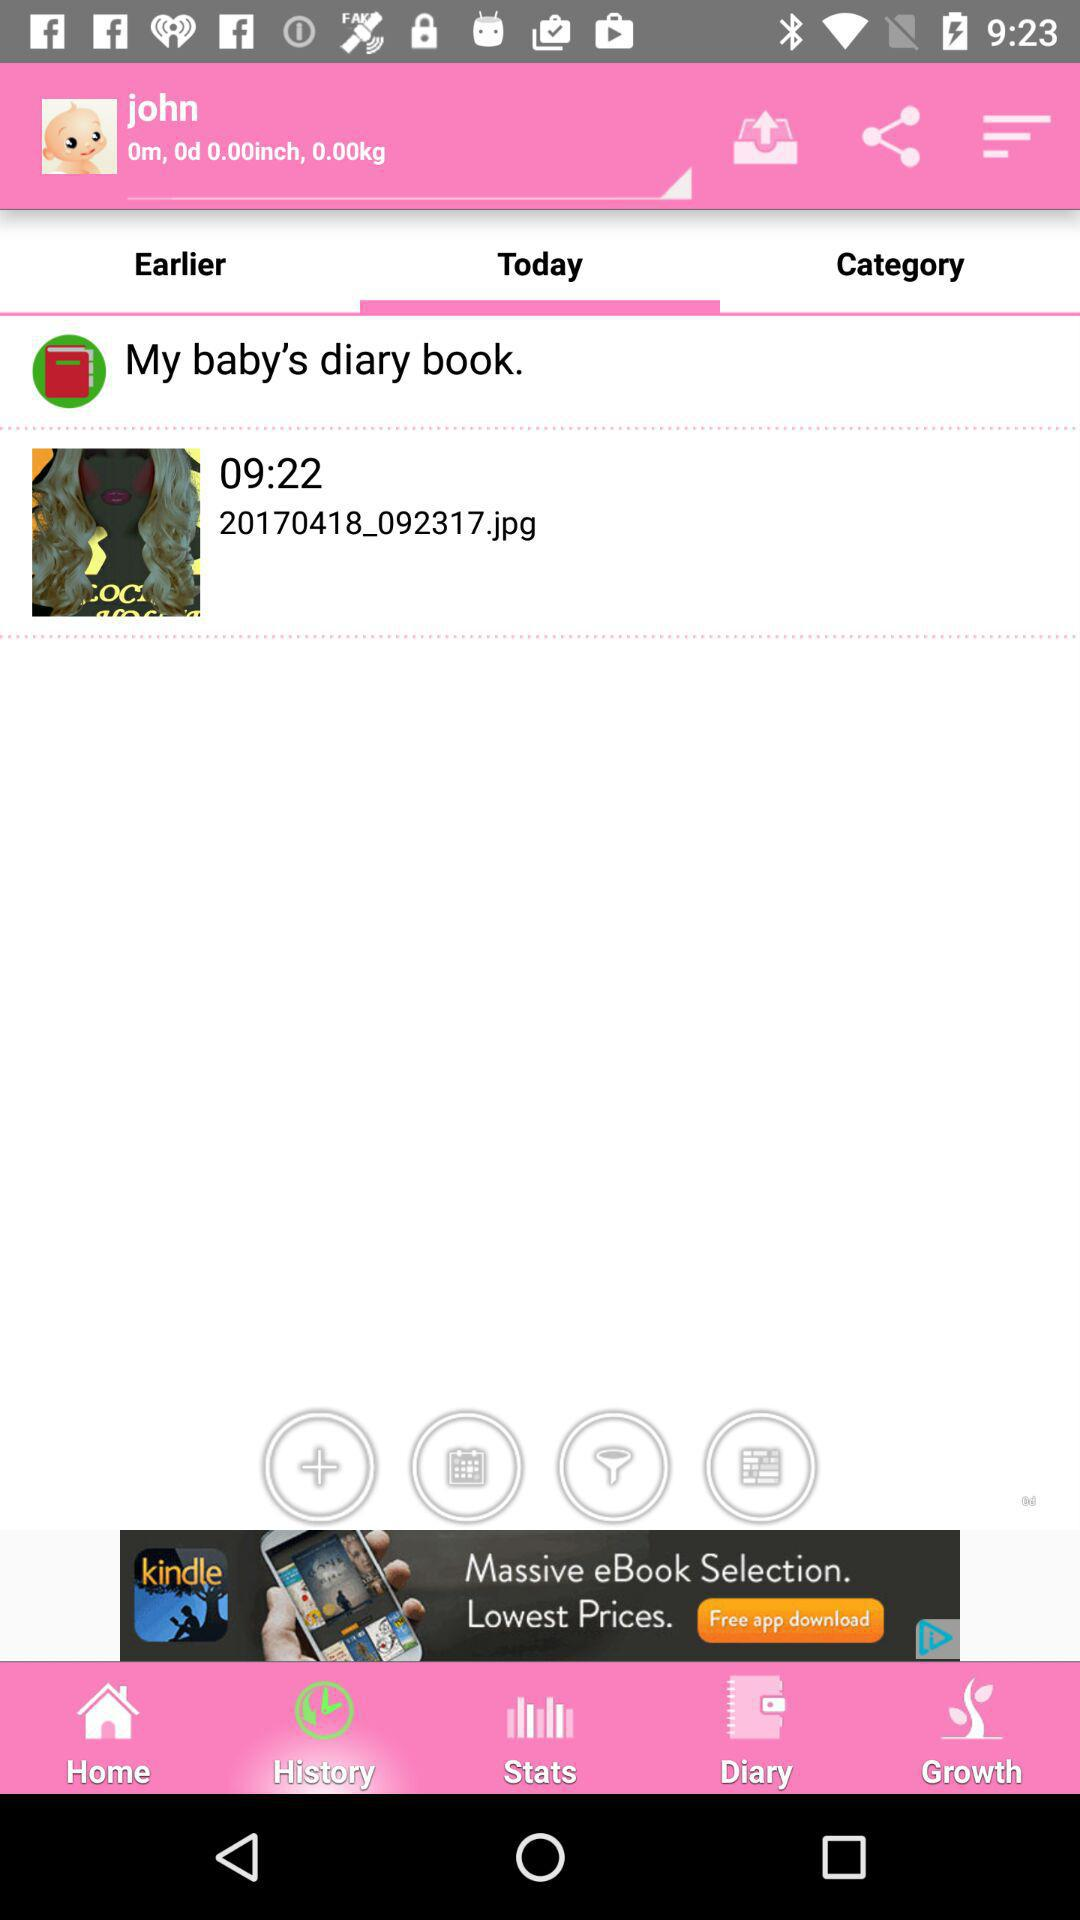What is the weight of the baby? The baby's weight is 0 kg. 